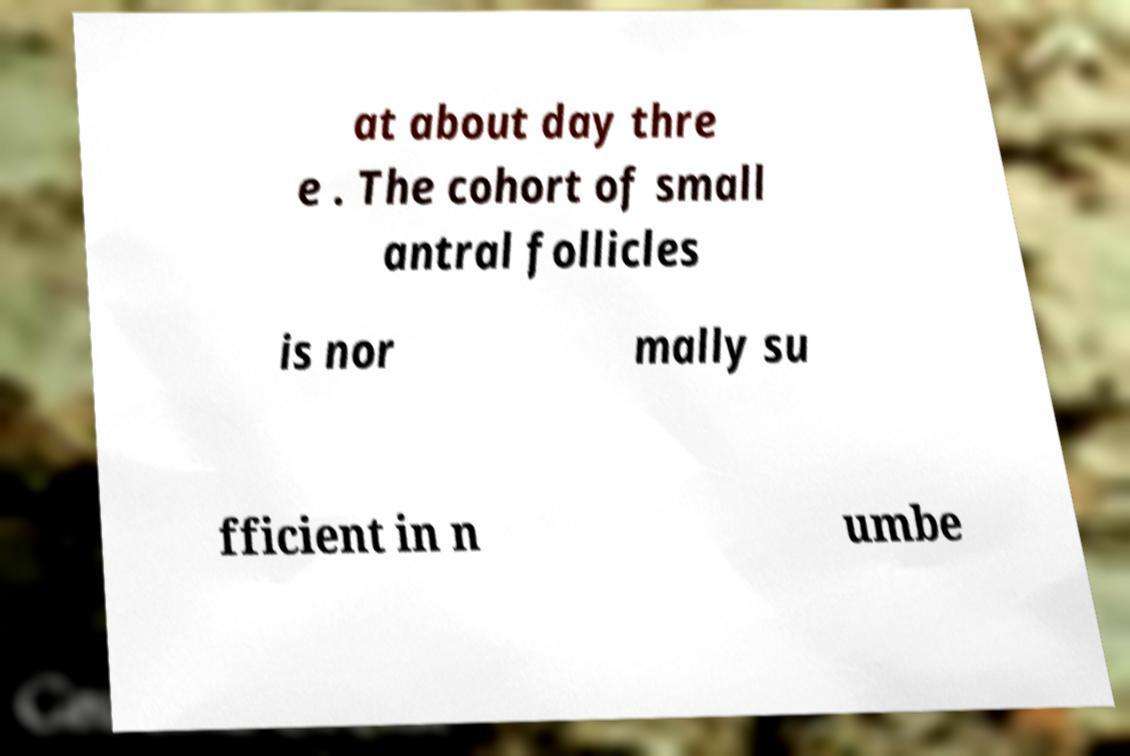There's text embedded in this image that I need extracted. Can you transcribe it verbatim? at about day thre e . The cohort of small antral follicles is nor mally su fficient in n umbe 